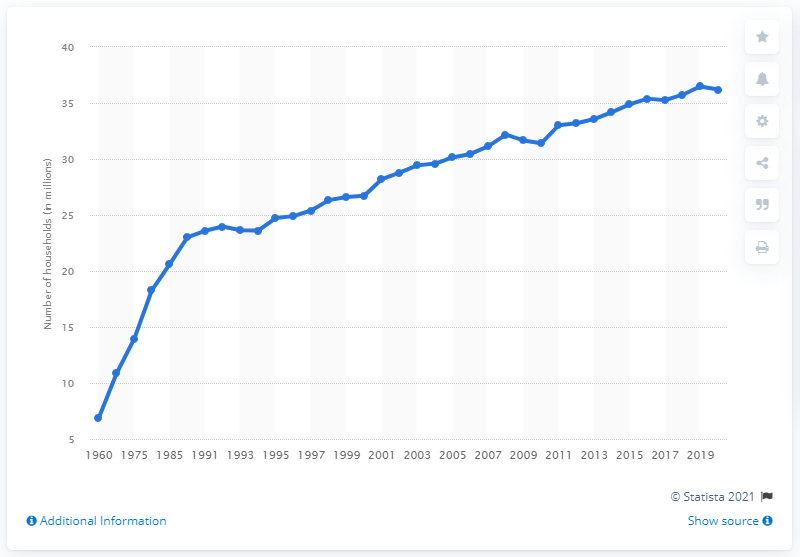Indicate a few pertinent items in this graphic. In the year 2020, the number of people living in single-person households in the United States was approximately 36.2 million. 